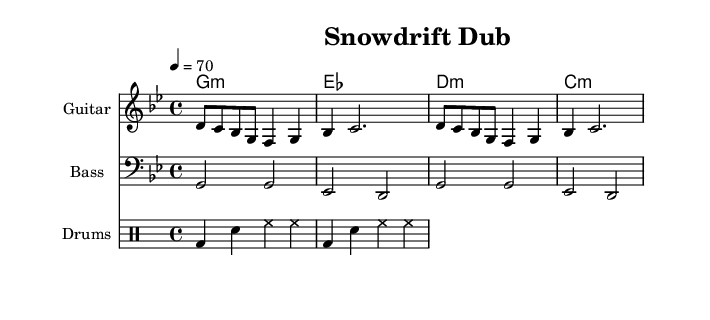What is the key signature of this music? The key signature shown is G minor, which has two flats (B flat and E flat). This can be determined by looking at the clef marking and the accompanying key signature indicated at the beginning of the score.
Answer: G minor What is the time signature of this music? The time signature indicated at the start of the score is 4/4, which means there are four beats in each measure and the quarter note receives one beat. This is revealed by looking at the symbol in front of the staff notation.
Answer: 4/4 What is the tempo marking of this piece? The tempo marking shown above the staff indicates a speed of 70 beats per minute, which refers to the number of quarter note beats in one minute. This can be inferred from the number placed next to the word "tempo."
Answer: 70 How many measures are in the bass line? There are four measures in the bass line, which is evident from counting the segments divided by vertical bar lines in the provided notation. Each segment represents one measure.
Answer: 4 Which instrument plays the melody? The melody is played by the guitar, as indicated by the instrument name written above the staff containing the treble clef notes, and the specific notation for guitar is also used.
Answer: Guitar What type of music is represented in this sheet music? The sheet music represents reggae-influenced dub, characterized by its rhythm and instrumentation. The elements such as bass-heavy grooves and the laid-back tempo reflect the characteristics of reggae and dub genres.
Answer: Reggae-influenced dub What rhythmic instrument is represented in the drum pattern? The drum pattern represents the drums, as shown by the notation in the separate staff labeled "Drums" and the specific drum notations used, which correspond to typical reggae styles.
Answer: Drums 